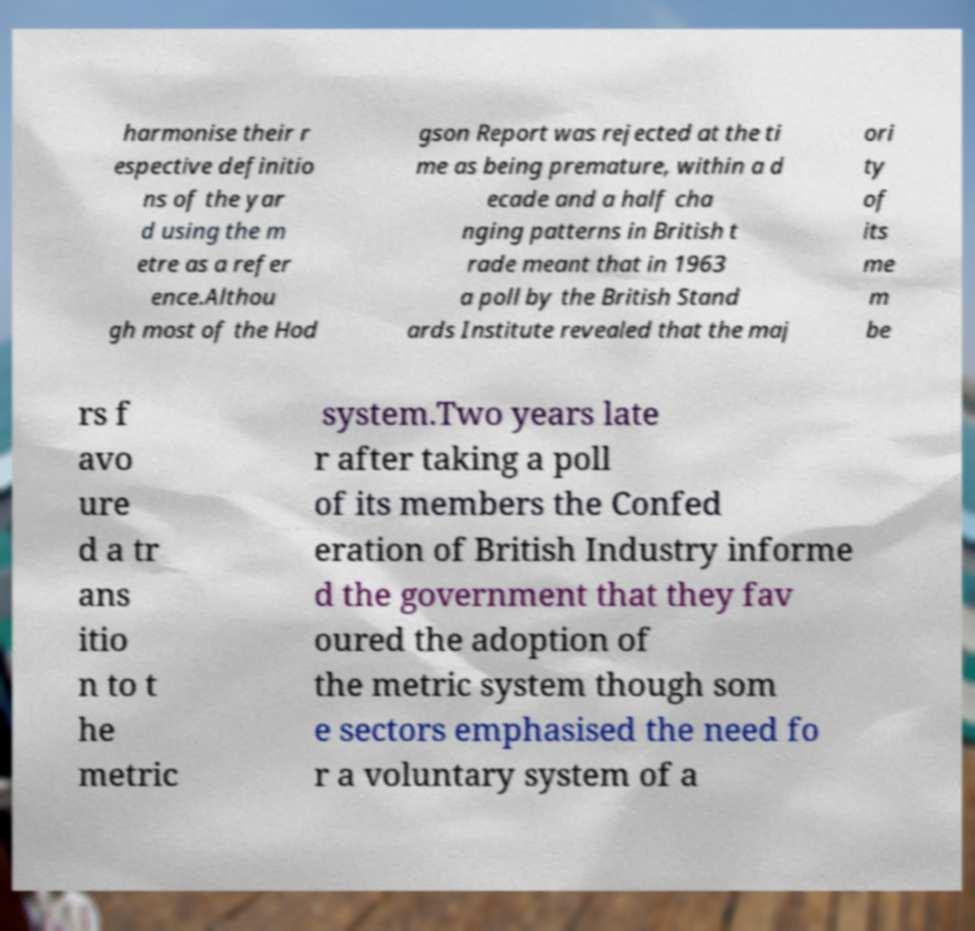For documentation purposes, I need the text within this image transcribed. Could you provide that? harmonise their r espective definitio ns of the yar d using the m etre as a refer ence.Althou gh most of the Hod gson Report was rejected at the ti me as being premature, within a d ecade and a half cha nging patterns in British t rade meant that in 1963 a poll by the British Stand ards Institute revealed that the maj ori ty of its me m be rs f avo ure d a tr ans itio n to t he metric system.Two years late r after taking a poll of its members the Confed eration of British Industry informe d the government that they fav oured the adoption of the metric system though som e sectors emphasised the need fo r a voluntary system of a 